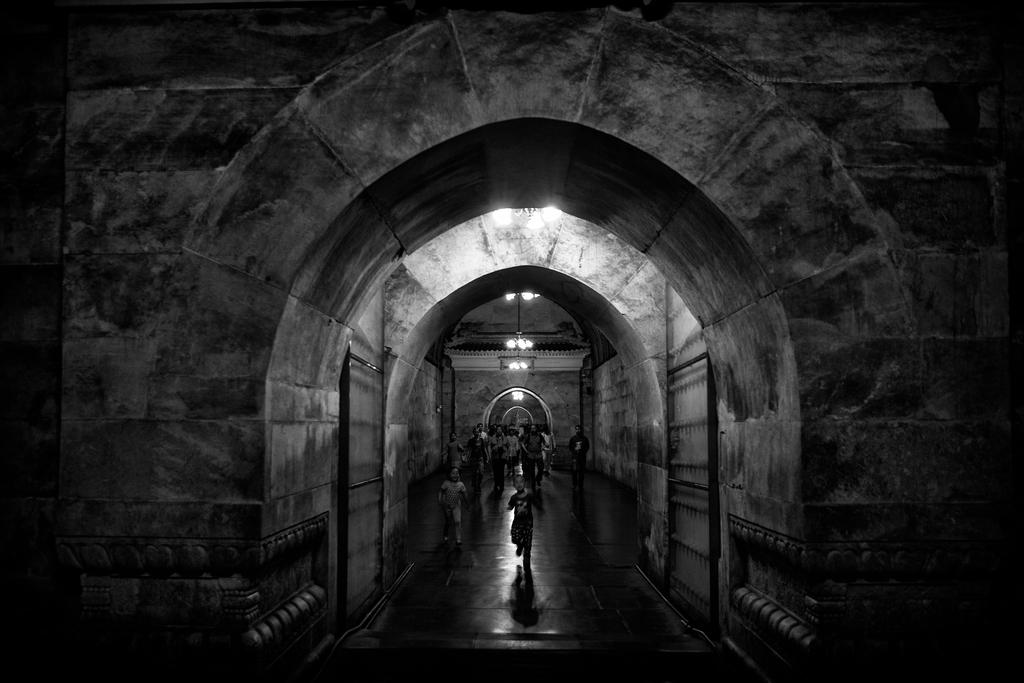What is the color scheme of the image? The image is black and white. What can be seen in the middle of the image? There are people walking in the middle of a building. What is visible at the top of the image? There are lights visible at the top of the image. Can you see a frog hopping across the floor in the image? There is no frog present in the image. What type of match is being played in the image? There is no match or any indication of a game being played in the image. 